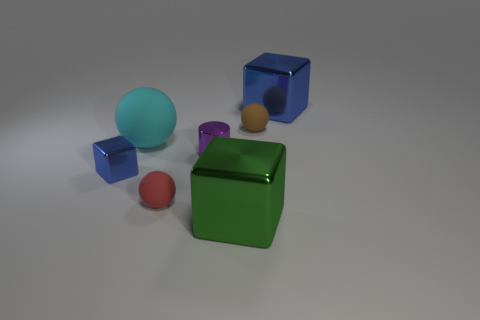There is a green metallic thing in front of the brown matte thing; what is its size?
Keep it short and to the point. Large. There is a blue shiny object that is left of the red matte ball; does it have the same shape as the red object?
Offer a terse response. No. There is a big thing that is the same shape as the small red matte thing; what material is it?
Provide a succinct answer. Rubber. Is there anything else that has the same size as the brown thing?
Your answer should be compact. Yes. Is there a green block?
Give a very brief answer. Yes. There is a blue thing in front of the blue metallic object that is on the right side of the cube that is in front of the red matte sphere; what is it made of?
Offer a very short reply. Metal. There is a small red object; is it the same shape as the metal object to the right of the green block?
Your response must be concise. No. How many brown objects have the same shape as the tiny blue shiny thing?
Provide a succinct answer. 0. What is the shape of the large matte object?
Provide a short and direct response. Sphere. There is a blue cube that is behind the tiny matte thing right of the tiny cylinder; what size is it?
Provide a short and direct response. Large. 